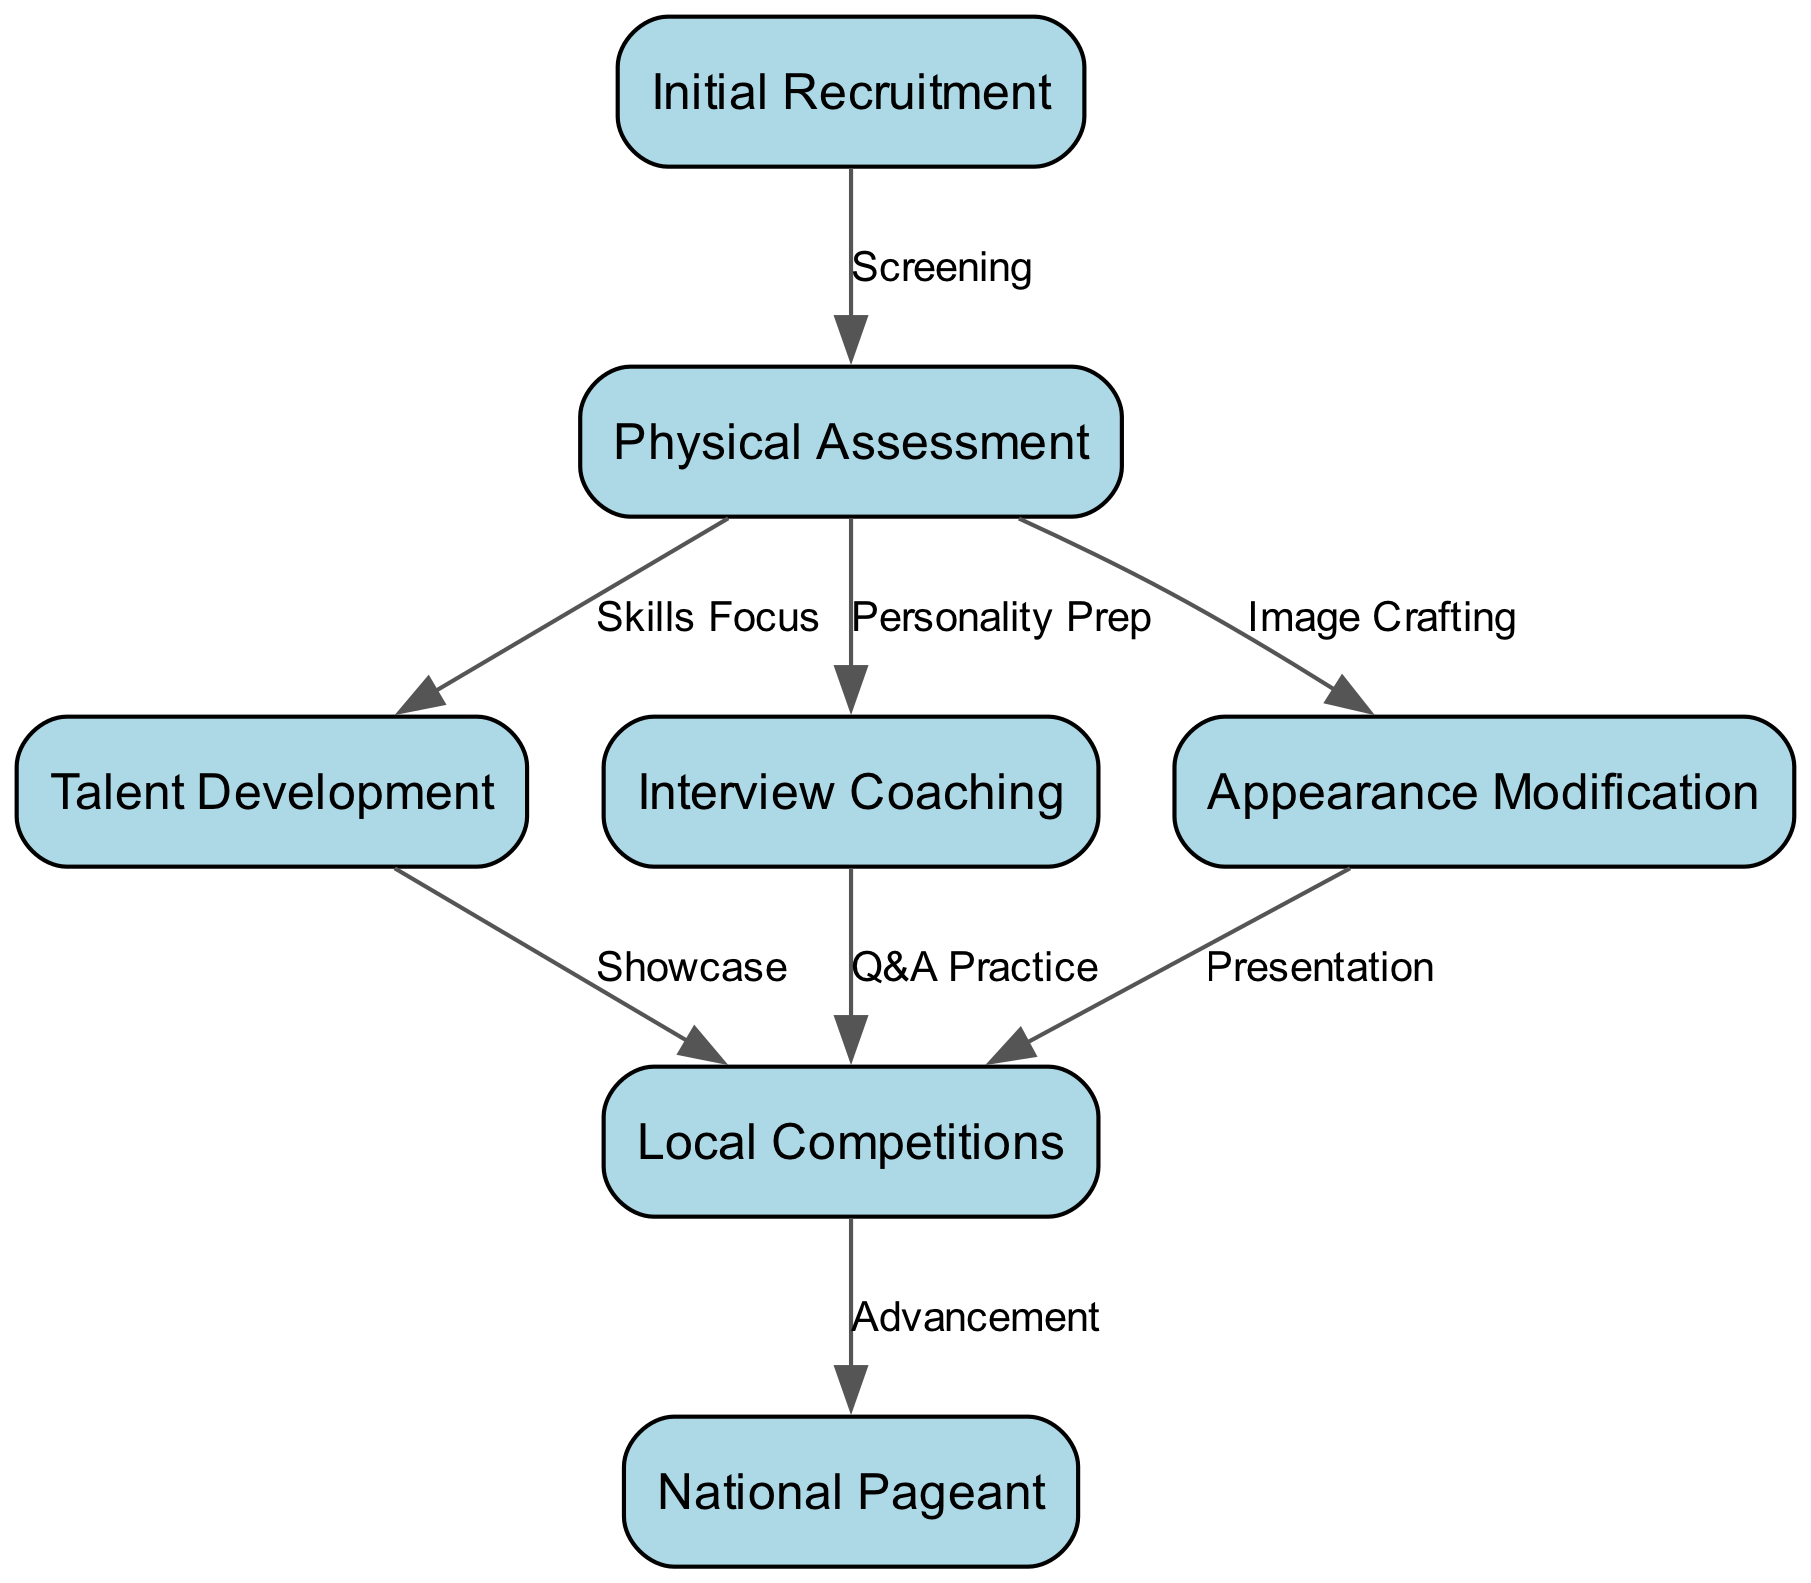What is the first step in the beauty pageant contestant training regimen? The diagram shows "Initial Recruitment" as the first node, indicating it is the starting point of the training regimen.
Answer: Initial Recruitment How many nodes are present in the diagram? By counting each labeled step in the training lifecycle, we identify seven nodes listed in the diagram.
Answer: 7 What is the last stage before a contestant reaches the National Pageant? The diagram indicates "Local Competitions" is the step leading directly to the "National Pageant" after it is completed.
Answer: Local Competitions What type of skill is focused on after the Physical Assessment? The diagram indicates that following the "Physical Assessment," the next focus is on "Talent Development," emphasizing the enhancement of contestant skills.
Answer: Talent Development Which two processes involve feedback from the Physical Assessment? The "Interview Coaching" and "Appearance Modification" steps both stem from the "Physical Assessment" node, indicating that feedback influences these processes.
Answer: Interview Coaching and Appearance Modification How many edges are there connecting the nodes in this diagram? By evaluating each connection (or edge) between the nodes, we find that there are six edges present in the diagram that outline the relationships between the steps.
Answer: 6 What practice occurs between Interview Coaching and Local Competitions? The diagram illustrates that "Q&A Practice" is the direct connection between "Interview Coaching" and "Local Competitions," indicating this step prepares contestants for questions in competitions.
Answer: Q&A Practice Which nodes are directly connected to the Physical Assessment? The diagram shows three processes ("Talent Development," "Interview Coaching," and "Appearance Modification") linked directly to "Physical Assessment."
Answer: Talent Development, Interview Coaching, Appearance Modification What does the arrow labeled "Advancement" signify in the diagram? The arrow labeled "Advancement" signifies that after completing "Local Competitions," contestants progress to the "National Pageant," marking a significant advancement in their journey.
Answer: Advancement 